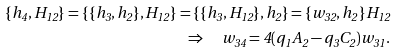Convert formula to latex. <formula><loc_0><loc_0><loc_500><loc_500>\{ h _ { 4 } , H _ { 1 2 } \} = \{ \{ h _ { 3 } , h _ { 2 } \} , H _ { 1 2 } \} = \{ \{ h _ { 3 } , H _ { 1 2 } \} , h _ { 2 } \} = \{ w _ { 3 2 } , h _ { 2 } \} H _ { 1 2 } \\ \Rightarrow \quad w _ { 3 4 } = 4 ( q _ { 1 } A _ { 2 } - q _ { 3 } C _ { 2 } ) w _ { 3 1 } .</formula> 